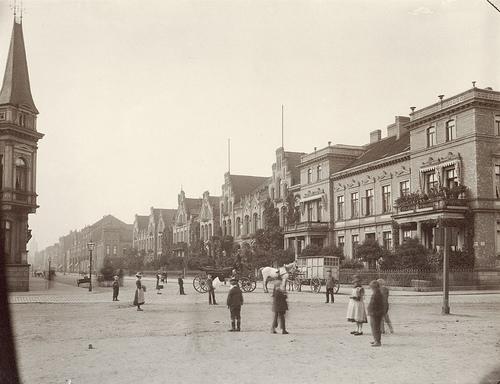What is on top of the steeple?
Give a very brief answer. Tower. How many people are in the foreground?
Be succinct. 5. Are there any roads able to be seen?
Short answer required. Yes. What type of animals are in the scene?
Quick response, please. Horse. What color is this photo?
Keep it brief. Black and white. Is a clock on the nearby tower?
Be succinct. No. Are there any motorcycles in the street?
Short answer required. No. Is this near a religious place?
Write a very short answer. No. Is this  photo old?
Give a very brief answer. Yes. How many people are shown?
Concise answer only. 12. How many lampposts do you see?
Write a very short answer. 3. How many horses are in this picture?
Be succinct. 1. 